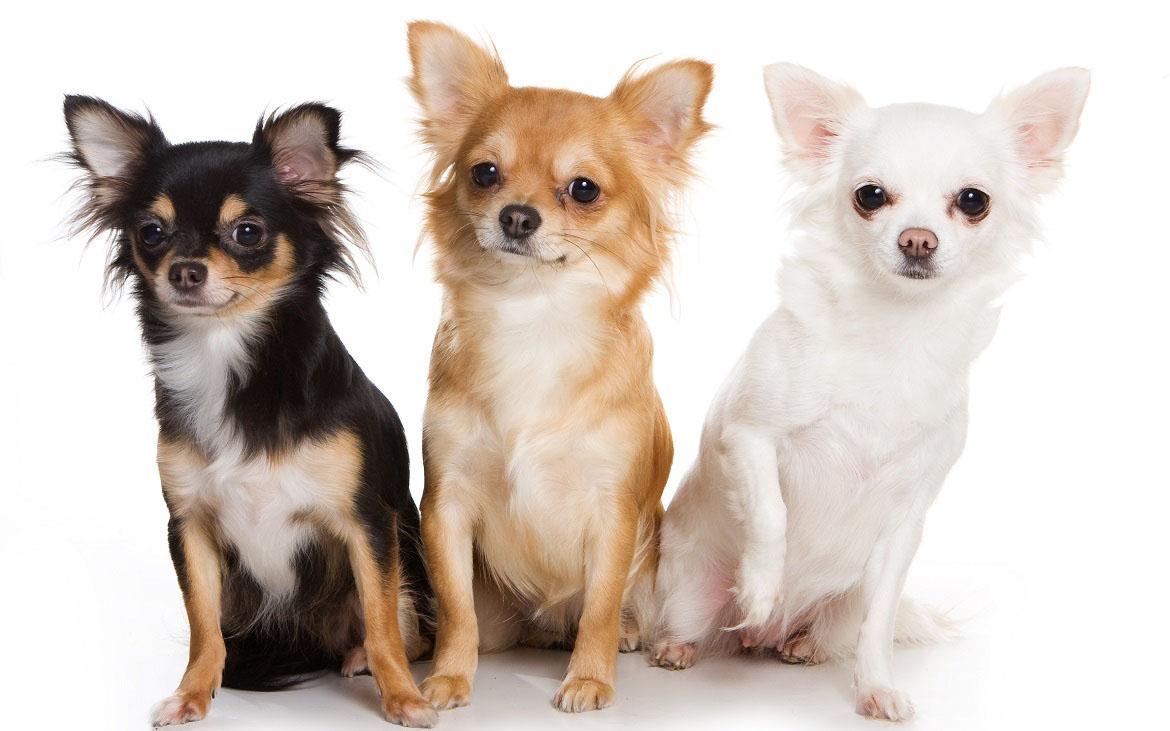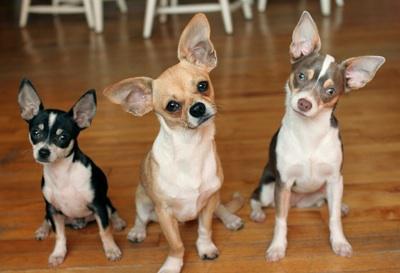The first image is the image on the left, the second image is the image on the right. For the images displayed, is the sentence "There are three chihuahuas in the right image." factually correct? Answer yes or no. Yes. The first image is the image on the left, the second image is the image on the right. Analyze the images presented: Is the assertion "Each image contains three dogs, and one set of dogs pose wearing only collars." valid? Answer yes or no. No. 